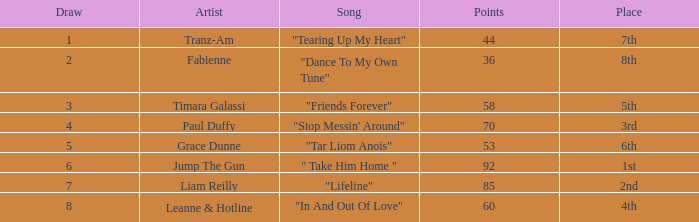What's the largest draw with more than 60 points for paul duffy? 4.0. 